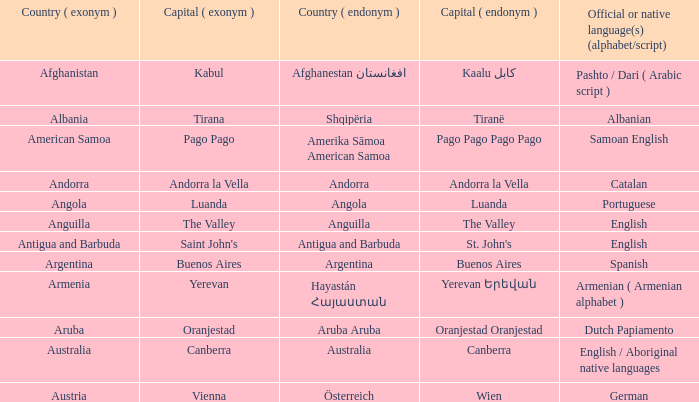What is the domestic title assigned to the city of canberra? Canberra. 